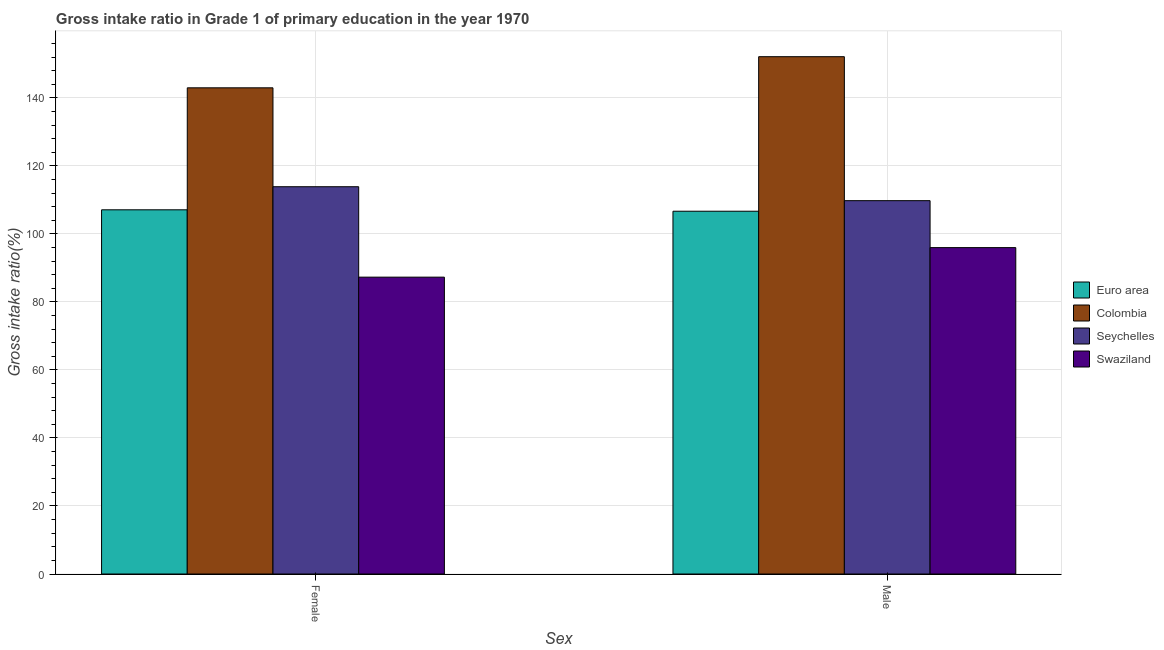Are the number of bars per tick equal to the number of legend labels?
Your response must be concise. Yes. How many bars are there on the 2nd tick from the left?
Provide a succinct answer. 4. What is the label of the 2nd group of bars from the left?
Ensure brevity in your answer.  Male. What is the gross intake ratio(female) in Seychelles?
Give a very brief answer. 113.86. Across all countries, what is the maximum gross intake ratio(male)?
Make the answer very short. 152.1. Across all countries, what is the minimum gross intake ratio(female)?
Provide a succinct answer. 87.28. In which country was the gross intake ratio(male) maximum?
Ensure brevity in your answer.  Colombia. In which country was the gross intake ratio(female) minimum?
Ensure brevity in your answer.  Swaziland. What is the total gross intake ratio(female) in the graph?
Your answer should be very brief. 451.17. What is the difference between the gross intake ratio(female) in Seychelles and that in Colombia?
Make the answer very short. -29.08. What is the difference between the gross intake ratio(male) in Seychelles and the gross intake ratio(female) in Swaziland?
Provide a short and direct response. 22.48. What is the average gross intake ratio(male) per country?
Offer a very short reply. 116.12. What is the difference between the gross intake ratio(male) and gross intake ratio(female) in Seychelles?
Make the answer very short. -4.1. What is the ratio of the gross intake ratio(female) in Colombia to that in Seychelles?
Your answer should be very brief. 1.26. Is the gross intake ratio(female) in Euro area less than that in Swaziland?
Offer a terse response. No. What does the 3rd bar from the left in Female represents?
Offer a very short reply. Seychelles. Are the values on the major ticks of Y-axis written in scientific E-notation?
Give a very brief answer. No. Does the graph contain any zero values?
Keep it short and to the point. No. Does the graph contain grids?
Your response must be concise. Yes. Where does the legend appear in the graph?
Make the answer very short. Center right. How many legend labels are there?
Offer a very short reply. 4. What is the title of the graph?
Give a very brief answer. Gross intake ratio in Grade 1 of primary education in the year 1970. Does "West Bank and Gaza" appear as one of the legend labels in the graph?
Offer a very short reply. No. What is the label or title of the X-axis?
Keep it short and to the point. Sex. What is the label or title of the Y-axis?
Your answer should be very brief. Gross intake ratio(%). What is the Gross intake ratio(%) in Euro area in Female?
Ensure brevity in your answer.  107.08. What is the Gross intake ratio(%) of Colombia in Female?
Provide a short and direct response. 142.94. What is the Gross intake ratio(%) in Seychelles in Female?
Offer a very short reply. 113.86. What is the Gross intake ratio(%) in Swaziland in Female?
Provide a short and direct response. 87.28. What is the Gross intake ratio(%) in Euro area in Male?
Keep it short and to the point. 106.66. What is the Gross intake ratio(%) in Colombia in Male?
Offer a very short reply. 152.1. What is the Gross intake ratio(%) in Seychelles in Male?
Ensure brevity in your answer.  109.77. What is the Gross intake ratio(%) in Swaziland in Male?
Offer a terse response. 95.96. Across all Sex, what is the maximum Gross intake ratio(%) of Euro area?
Provide a succinct answer. 107.08. Across all Sex, what is the maximum Gross intake ratio(%) in Colombia?
Your answer should be very brief. 152.1. Across all Sex, what is the maximum Gross intake ratio(%) of Seychelles?
Your answer should be very brief. 113.86. Across all Sex, what is the maximum Gross intake ratio(%) in Swaziland?
Ensure brevity in your answer.  95.96. Across all Sex, what is the minimum Gross intake ratio(%) of Euro area?
Ensure brevity in your answer.  106.66. Across all Sex, what is the minimum Gross intake ratio(%) of Colombia?
Make the answer very short. 142.94. Across all Sex, what is the minimum Gross intake ratio(%) in Seychelles?
Your response must be concise. 109.77. Across all Sex, what is the minimum Gross intake ratio(%) in Swaziland?
Provide a short and direct response. 87.28. What is the total Gross intake ratio(%) in Euro area in the graph?
Your answer should be very brief. 213.74. What is the total Gross intake ratio(%) of Colombia in the graph?
Provide a short and direct response. 295.04. What is the total Gross intake ratio(%) in Seychelles in the graph?
Give a very brief answer. 223.63. What is the total Gross intake ratio(%) in Swaziland in the graph?
Give a very brief answer. 183.24. What is the difference between the Gross intake ratio(%) in Euro area in Female and that in Male?
Keep it short and to the point. 0.42. What is the difference between the Gross intake ratio(%) in Colombia in Female and that in Male?
Provide a short and direct response. -9.15. What is the difference between the Gross intake ratio(%) in Seychelles in Female and that in Male?
Your answer should be very brief. 4.1. What is the difference between the Gross intake ratio(%) of Swaziland in Female and that in Male?
Your response must be concise. -8.68. What is the difference between the Gross intake ratio(%) of Euro area in Female and the Gross intake ratio(%) of Colombia in Male?
Give a very brief answer. -45.02. What is the difference between the Gross intake ratio(%) in Euro area in Female and the Gross intake ratio(%) in Seychelles in Male?
Offer a terse response. -2.69. What is the difference between the Gross intake ratio(%) in Euro area in Female and the Gross intake ratio(%) in Swaziland in Male?
Give a very brief answer. 11.12. What is the difference between the Gross intake ratio(%) in Colombia in Female and the Gross intake ratio(%) in Seychelles in Male?
Provide a succinct answer. 33.18. What is the difference between the Gross intake ratio(%) in Colombia in Female and the Gross intake ratio(%) in Swaziland in Male?
Offer a very short reply. 46.98. What is the difference between the Gross intake ratio(%) in Seychelles in Female and the Gross intake ratio(%) in Swaziland in Male?
Provide a short and direct response. 17.9. What is the average Gross intake ratio(%) of Euro area per Sex?
Your answer should be compact. 106.87. What is the average Gross intake ratio(%) of Colombia per Sex?
Your answer should be very brief. 147.52. What is the average Gross intake ratio(%) in Seychelles per Sex?
Your answer should be very brief. 111.81. What is the average Gross intake ratio(%) in Swaziland per Sex?
Give a very brief answer. 91.62. What is the difference between the Gross intake ratio(%) of Euro area and Gross intake ratio(%) of Colombia in Female?
Give a very brief answer. -35.86. What is the difference between the Gross intake ratio(%) of Euro area and Gross intake ratio(%) of Seychelles in Female?
Provide a succinct answer. -6.78. What is the difference between the Gross intake ratio(%) in Euro area and Gross intake ratio(%) in Swaziland in Female?
Keep it short and to the point. 19.8. What is the difference between the Gross intake ratio(%) of Colombia and Gross intake ratio(%) of Seychelles in Female?
Make the answer very short. 29.08. What is the difference between the Gross intake ratio(%) of Colombia and Gross intake ratio(%) of Swaziland in Female?
Keep it short and to the point. 55.66. What is the difference between the Gross intake ratio(%) of Seychelles and Gross intake ratio(%) of Swaziland in Female?
Give a very brief answer. 26.58. What is the difference between the Gross intake ratio(%) of Euro area and Gross intake ratio(%) of Colombia in Male?
Keep it short and to the point. -45.43. What is the difference between the Gross intake ratio(%) in Euro area and Gross intake ratio(%) in Seychelles in Male?
Provide a short and direct response. -3.1. What is the difference between the Gross intake ratio(%) of Euro area and Gross intake ratio(%) of Swaziland in Male?
Offer a very short reply. 10.7. What is the difference between the Gross intake ratio(%) in Colombia and Gross intake ratio(%) in Seychelles in Male?
Keep it short and to the point. 42.33. What is the difference between the Gross intake ratio(%) in Colombia and Gross intake ratio(%) in Swaziland in Male?
Ensure brevity in your answer.  56.13. What is the difference between the Gross intake ratio(%) of Seychelles and Gross intake ratio(%) of Swaziland in Male?
Keep it short and to the point. 13.8. What is the ratio of the Gross intake ratio(%) of Colombia in Female to that in Male?
Offer a terse response. 0.94. What is the ratio of the Gross intake ratio(%) in Seychelles in Female to that in Male?
Offer a very short reply. 1.04. What is the ratio of the Gross intake ratio(%) in Swaziland in Female to that in Male?
Offer a very short reply. 0.91. What is the difference between the highest and the second highest Gross intake ratio(%) in Euro area?
Make the answer very short. 0.42. What is the difference between the highest and the second highest Gross intake ratio(%) of Colombia?
Give a very brief answer. 9.15. What is the difference between the highest and the second highest Gross intake ratio(%) of Seychelles?
Offer a terse response. 4.1. What is the difference between the highest and the second highest Gross intake ratio(%) in Swaziland?
Your answer should be compact. 8.68. What is the difference between the highest and the lowest Gross intake ratio(%) of Euro area?
Provide a succinct answer. 0.42. What is the difference between the highest and the lowest Gross intake ratio(%) of Colombia?
Give a very brief answer. 9.15. What is the difference between the highest and the lowest Gross intake ratio(%) of Seychelles?
Your answer should be compact. 4.1. What is the difference between the highest and the lowest Gross intake ratio(%) of Swaziland?
Your answer should be compact. 8.68. 